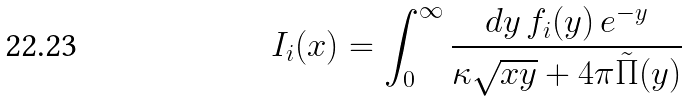Convert formula to latex. <formula><loc_0><loc_0><loc_500><loc_500>I _ { i } ( x ) = \int _ { 0 } ^ { \infty } \frac { d y \, f _ { i } ( y ) \, e ^ { - y } } { \kappa \sqrt { x y } + 4 \pi \tilde { \Pi } ( y ) }</formula> 